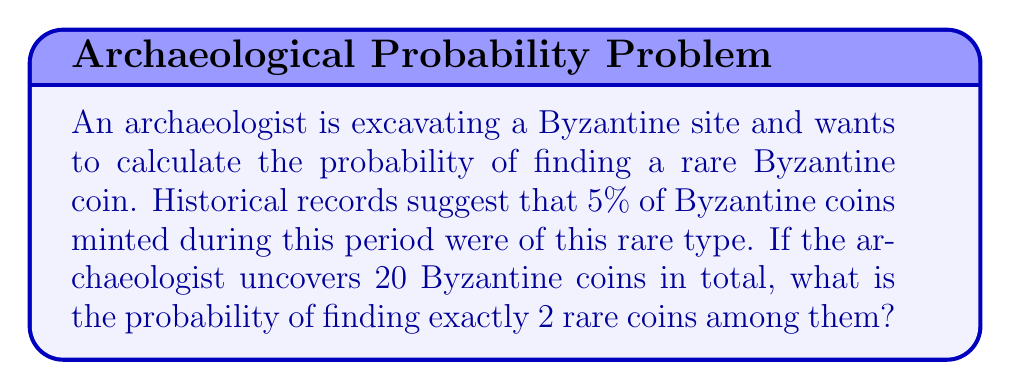Can you solve this math problem? This problem can be solved using the binomial probability distribution:

1) Let's define our variables:
   $n = 20$ (total number of coins)
   $k = 2$ (number of rare coins we want to find)
   $p = 0.05$ (probability of a coin being rare)

2) The binomial probability formula is:

   $$P(X=k) = \binom{n}{k} p^k (1-p)^{n-k}$$

3) Let's calculate each part:
   
   a) $\binom{n}{k} = \binom{20}{2} = \frac{20!}{2!(20-2)!} = 190$
   
   b) $p^k = 0.05^2 = 0.0025$
   
   c) $(1-p)^{n-k} = 0.95^{18} \approx 0.3972$

4) Now, let's put it all together:

   $$P(X=2) = 190 \times 0.0025 \times 0.3972 \approx 0.1886$$

5) Convert to percentage: $0.1886 \times 100\% = 18.86\%$

Therefore, the probability of finding exactly 2 rare Byzantine coins out of 20 is approximately 18.86%.
Answer: 18.86% 